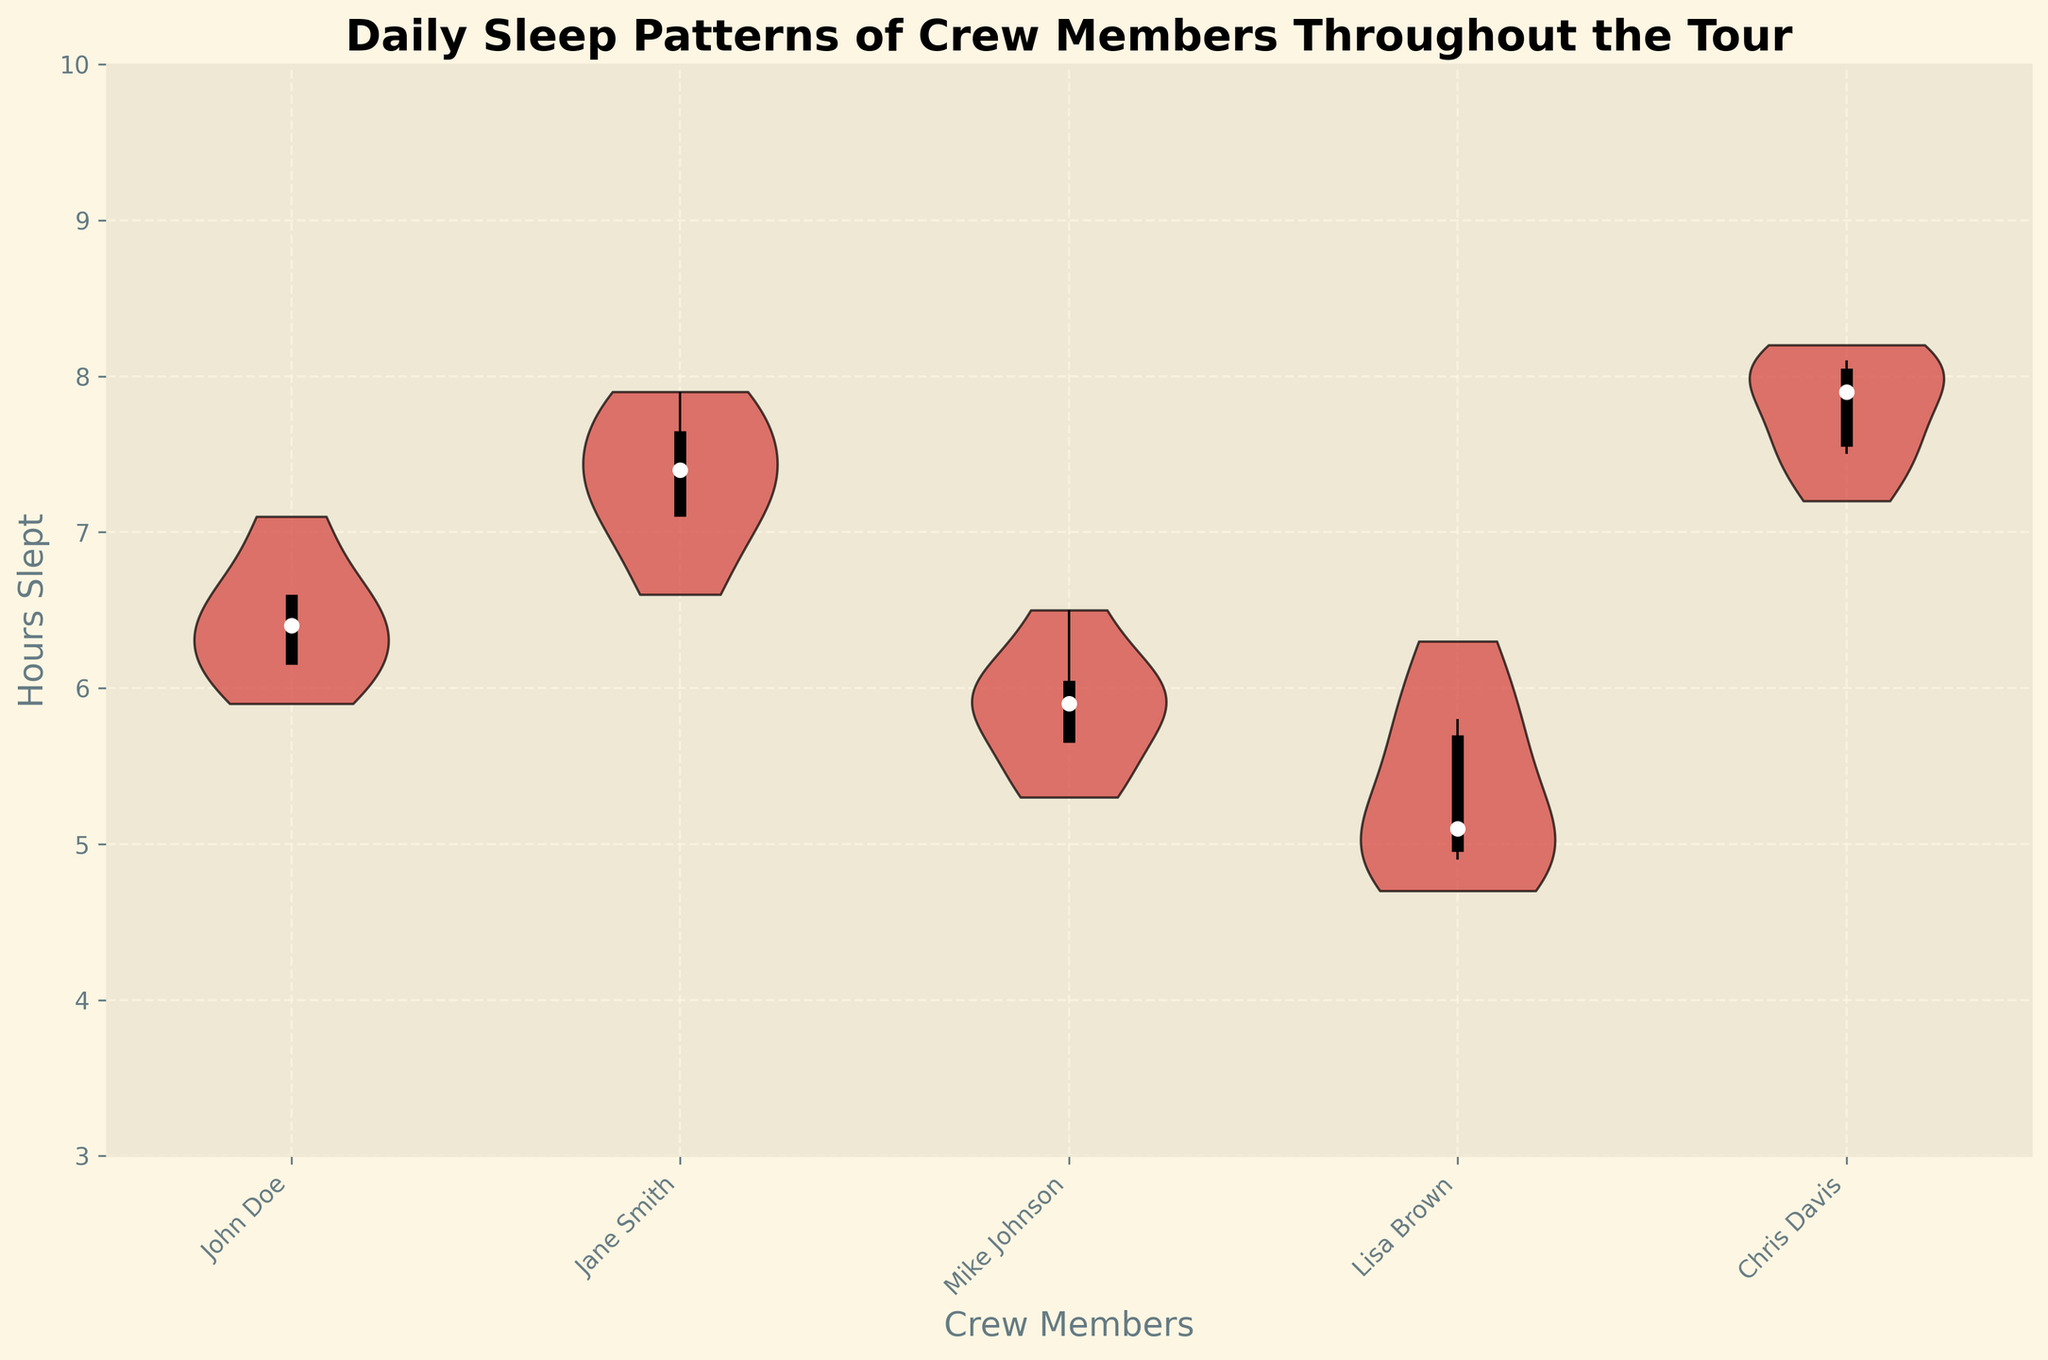what is the title of the plot? The title is found at the top of the plot. It provides an overview of what the plot represents.
Answer: Daily Sleep Patterns of Crew Members Throughout the Tour which crew member has the highest median sleep time? To determine this, locate the median points (white dots) for each crew member and identify the highest one.
Answer: Chris Davis what are the x-axis labels? The x-axis labels are located at the bottom of the plot and indicate the individual crew members.
Answer: John Doe, Jane Smith, Mike Johnson, Lisa Brown, Chris Davis what are the y-axis limits? The limits of the y-axis are the minimum and maximum values along this axis, showing the range of hours slept. These can be found on the left side of the plot.
Answer: 3 to 10 comparing Jane Smith and Mike Johnson, who has a wider interquartile range (IQR)? The IQR is represented by the length of the thick black vertical line. Compare the lines for Jane Smith and Mike Johnson.
Answer: Jane Smith which crew member has the lowest lower whisker value? To find the crew member with the lowest lower whisker, identify the shortest lower vertical line extending from the quartile boxes.
Answer: Lisa Brown what is the color of the violin plots? The color of the violin plots is observed directly in the figure.
Answer: Red comparing John Doe and Lisa Brown, who has a higher upper whisker value? The upper whisker value is identified by the top end of the thin black vertical line. Compare these between John Doe and Lisa Brown.
Answer: John Doe what does the median value represent in this plot? The median value is the midpoint of the data set for each crew member and is represented by the white dot in the violin plot. It shows the central tendency of the sleep hours.
Answer: Midpoint of sleep hours which crew member has the smallest variation in sleep hours? The smallest variation is indicated by the narrowest violin plot and the shortest distance between the whiskers.
Answer: John Doe 